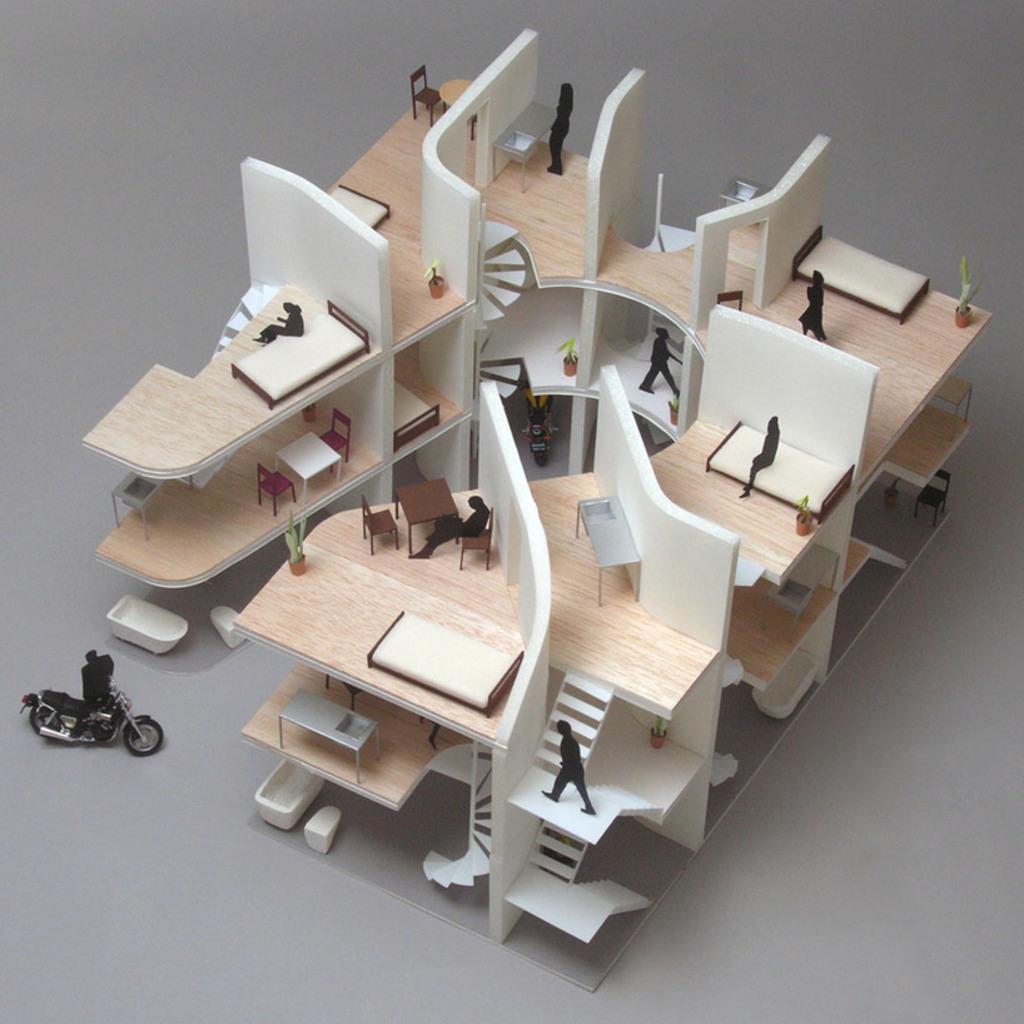Please provide a concise description of this image. In the center of the image, we can see a design engine architects on the table. 